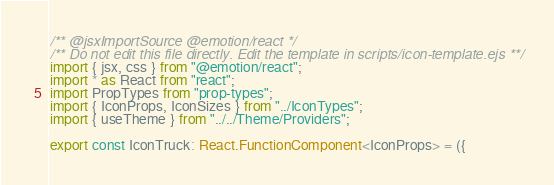Convert code to text. <code><loc_0><loc_0><loc_500><loc_500><_TypeScript_>/** @jsxImportSource @emotion/react */
/** Do not edit this file directly. Edit the template in scripts/icon-template.ejs **/
import { jsx, css } from "@emotion/react";
import * as React from "react";
import PropTypes from "prop-types";
import { IconProps, IconSizes } from "../IconTypes";
import { useTheme } from "../../Theme/Providers";

export const IconTruck: React.FunctionComponent<IconProps> = ({</code> 